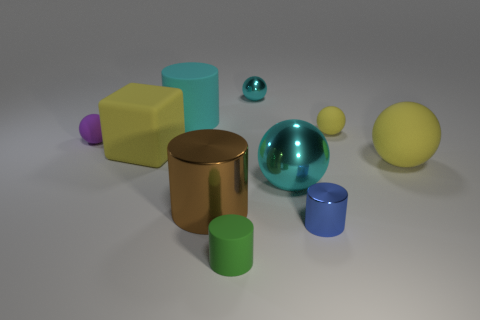Subtract all brown spheres. Subtract all purple cylinders. How many spheres are left? 5 Subtract all cubes. How many objects are left? 9 Add 3 large cyan cylinders. How many large cyan cylinders are left? 4 Add 8 big green blocks. How many big green blocks exist? 8 Subtract 0 green balls. How many objects are left? 10 Subtract all metal spheres. Subtract all yellow balls. How many objects are left? 6 